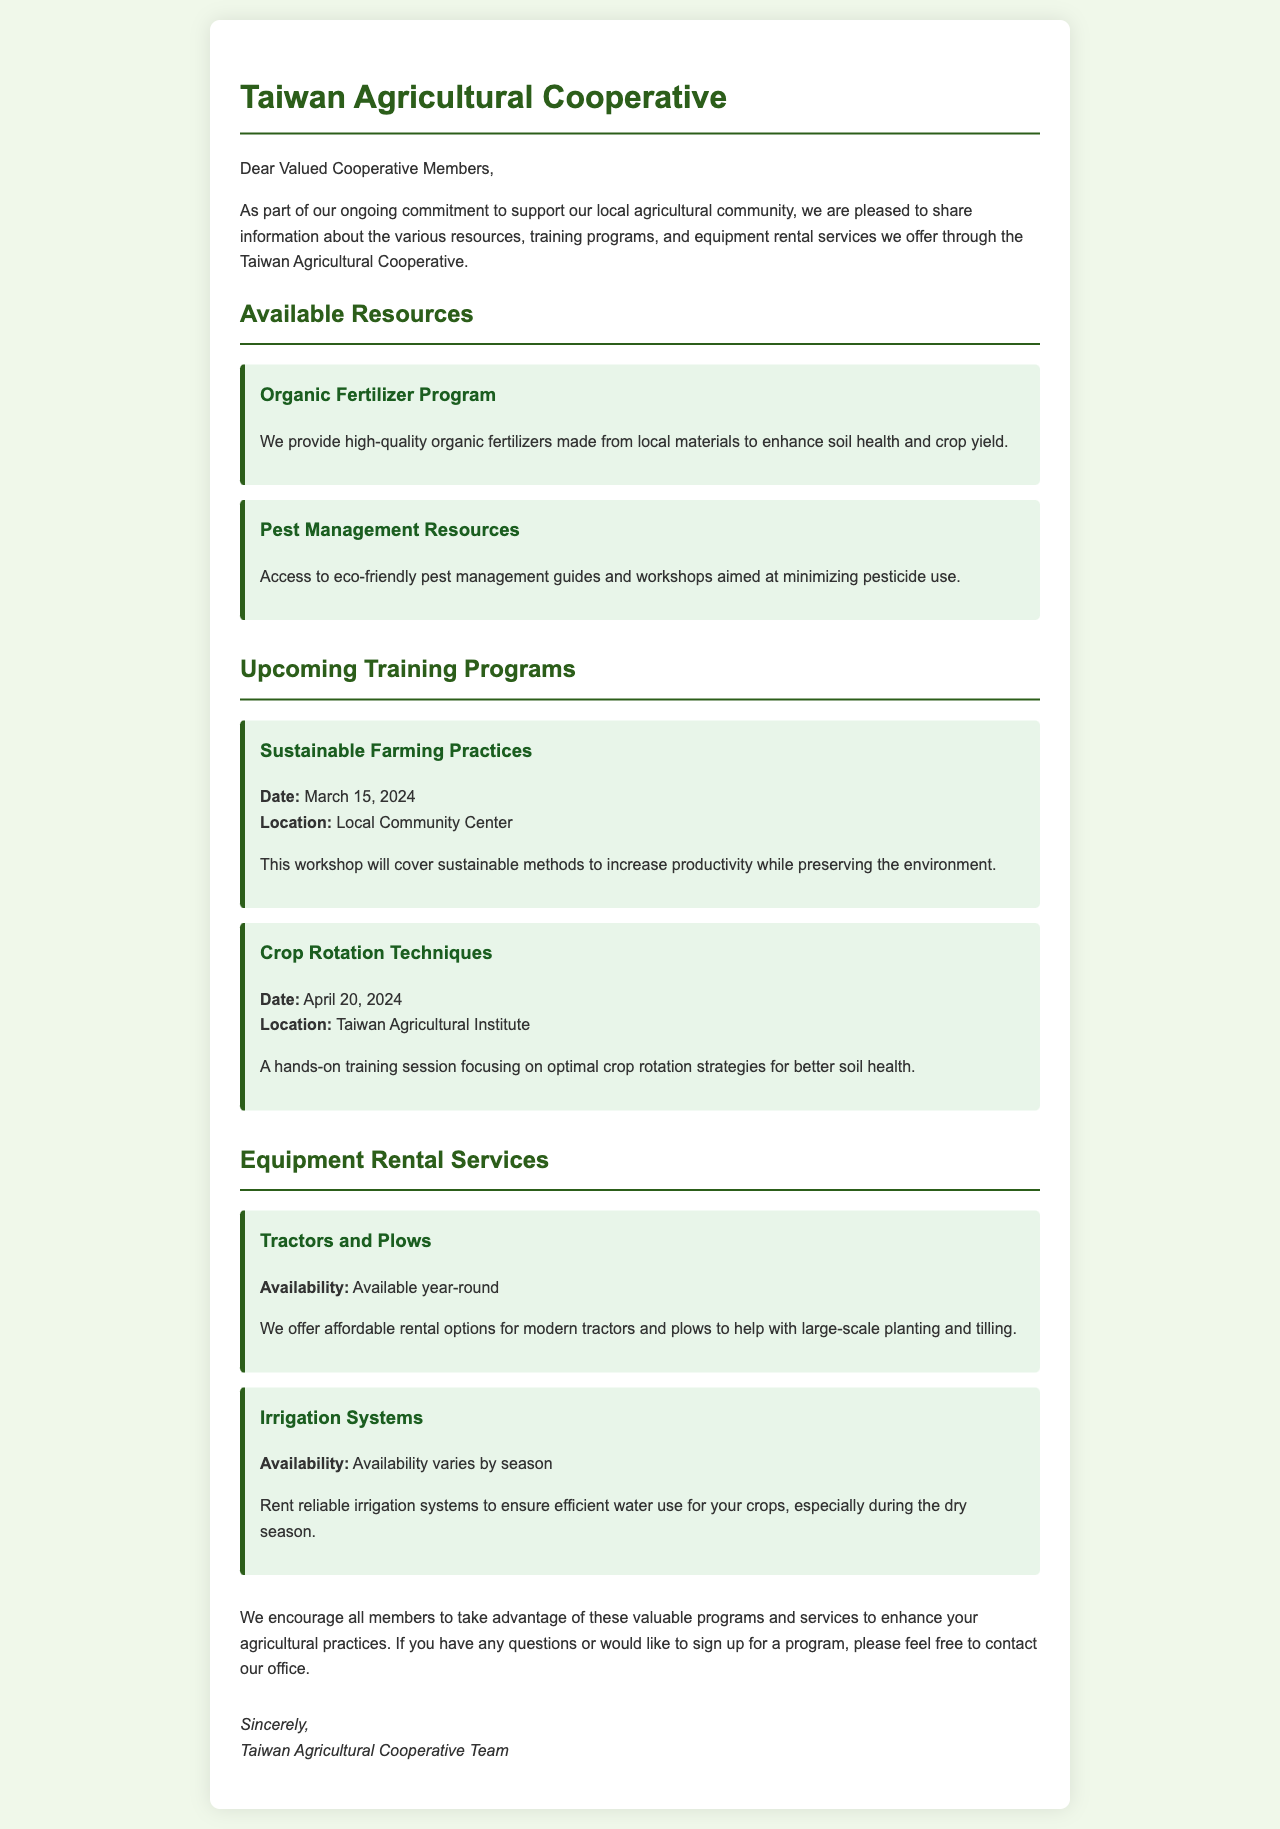what is the program for pest management resources? The document states that access to eco-friendly pest management guides and workshops is available.
Answer: eco-friendly pest management guides and workshops when is the sustainable farming practices workshop? The document specifies the date of this workshop as March 15, 2024.
Answer: March 15, 2024 who is the sender of the letter? The document concludes with the signature of the Taiwan Agricultural Cooperative Team as the sender.
Answer: Taiwan Agricultural Cooperative Team what equipment is available for rental year-round? The document mentions that tractors and plows are available for rental year-round.
Answer: Tractors and Plows where is the crop rotation techniques training session held? The document indicates that this training session is held at the Taiwan Agricultural Institute.
Answer: Taiwan Agricultural Institute what is the availability of irrigation systems for rent? The document states that the availability of irrigation systems varies by season.
Answer: varies by season what type of fertilizer program does the cooperative offer? The document mentions that they provide high-quality organic fertilizers.
Answer: Organic Fertilizer Program which method is emphasized in the sustainable farming practices workshop? The document specifies that the workshop will cover sustainable methods to increase productivity while preserving the environment.
Answer: sustainable methods to increase productivity while preserving the environment 